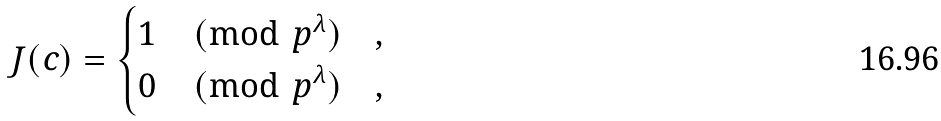Convert formula to latex. <formula><loc_0><loc_0><loc_500><loc_500>J ( c ) = \begin{cases} 1 \pmod { p ^ { \lambda } } & , \\ 0 \pmod { p ^ { \lambda } } & , \end{cases}</formula> 